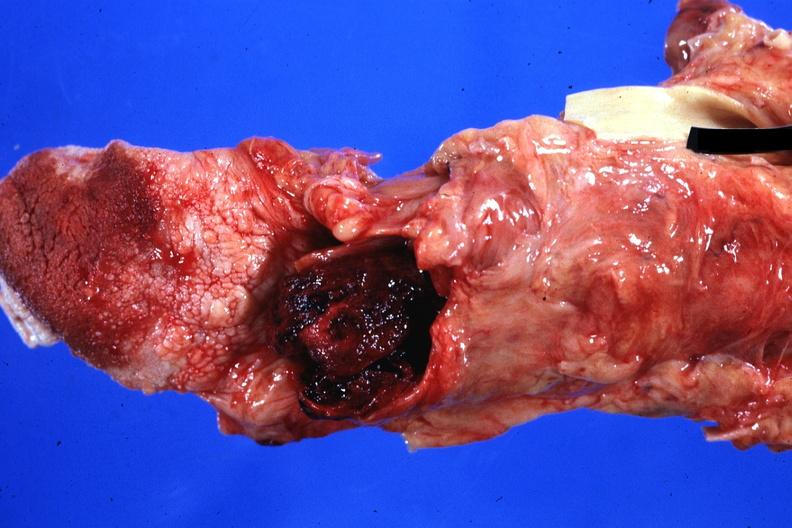where is this?
Answer the question using a single word or phrase. Oral 